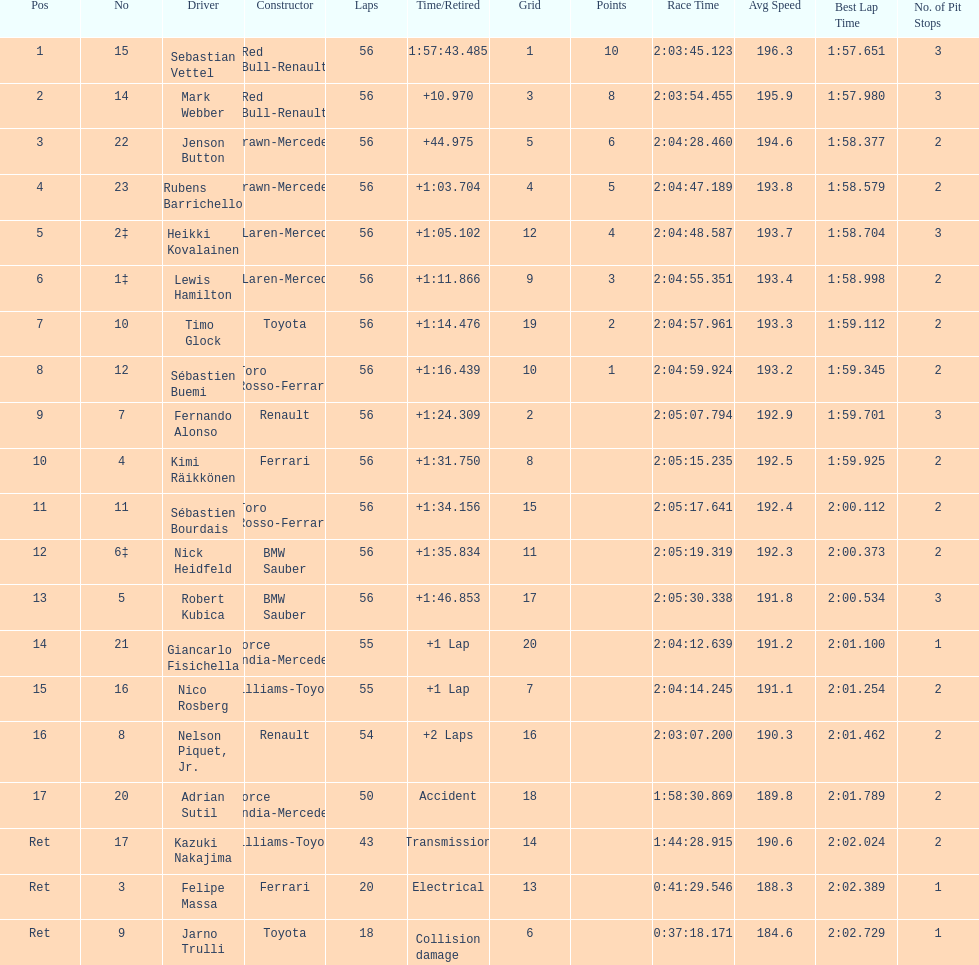What driver was last on the list? Jarno Trulli. 